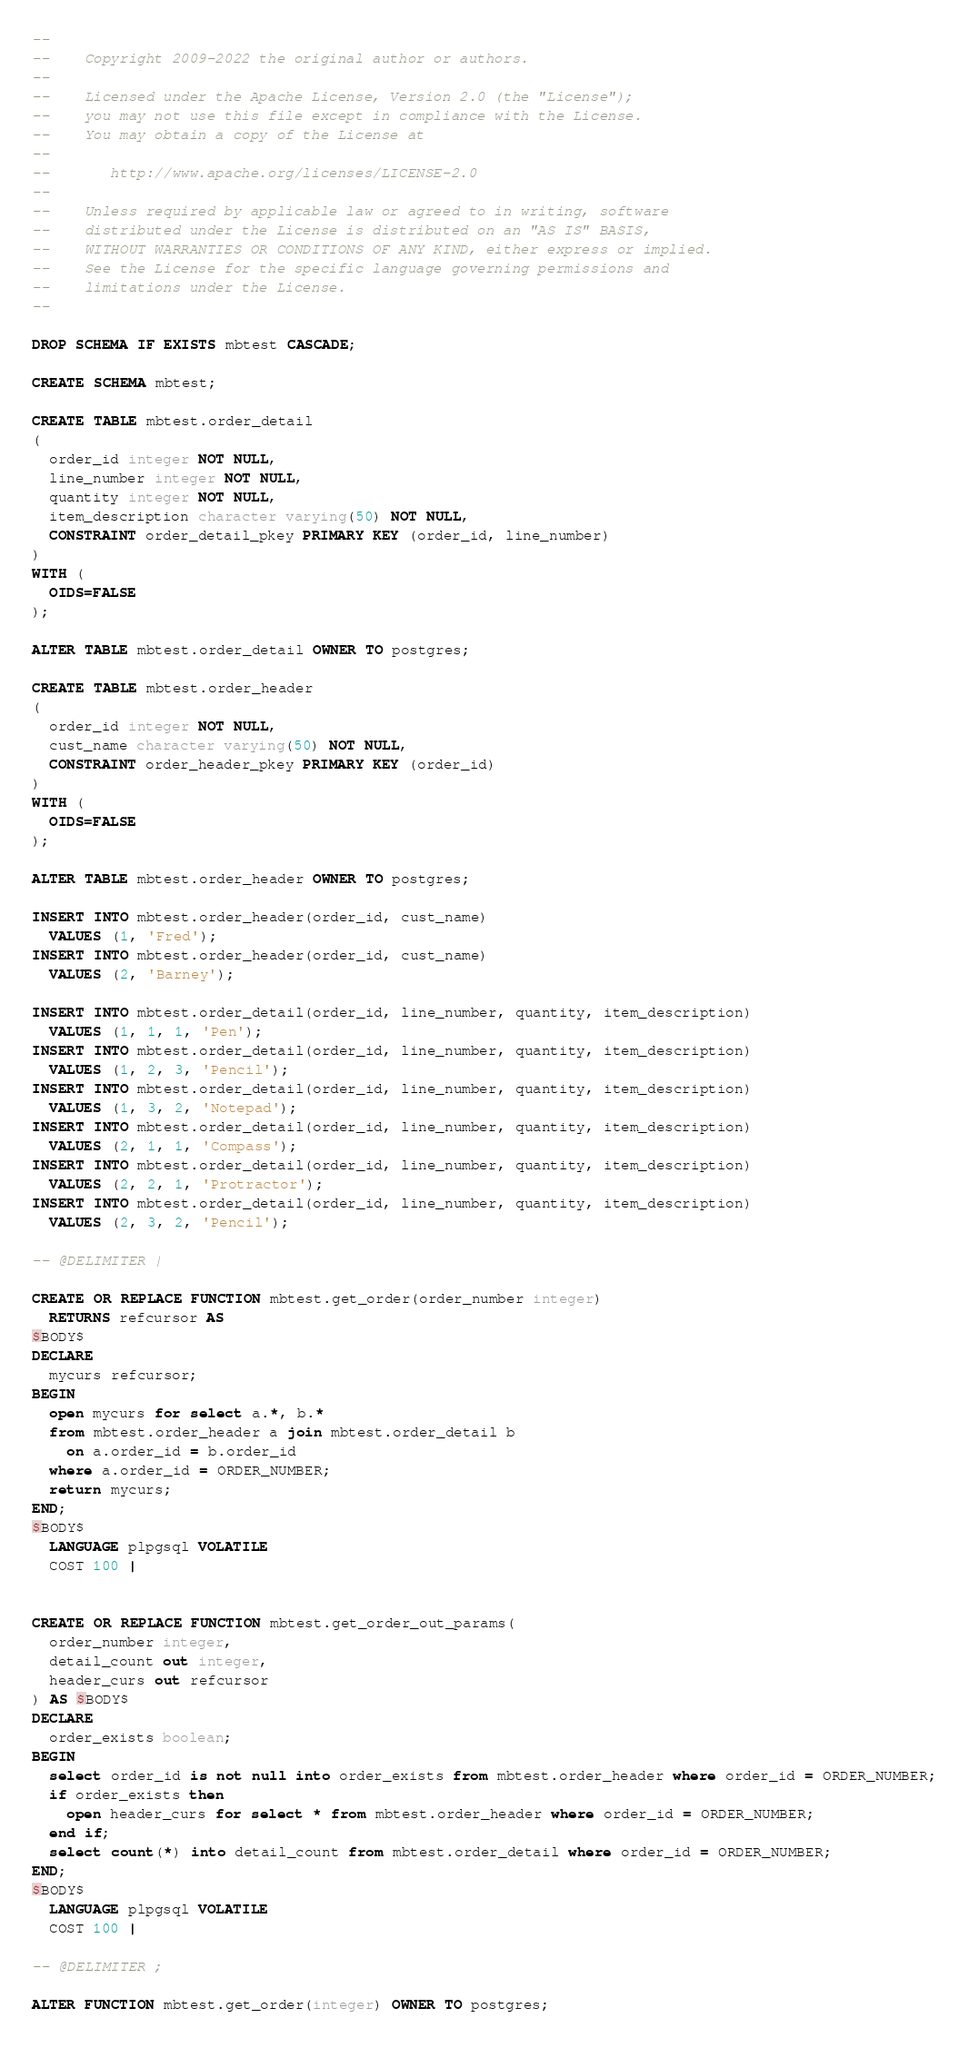Convert code to text. <code><loc_0><loc_0><loc_500><loc_500><_SQL_>--
--    Copyright 2009-2022 the original author or authors.
--
--    Licensed under the Apache License, Version 2.0 (the "License");
--    you may not use this file except in compliance with the License.
--    You may obtain a copy of the License at
--
--       http://www.apache.org/licenses/LICENSE-2.0
--
--    Unless required by applicable law or agreed to in writing, software
--    distributed under the License is distributed on an "AS IS" BASIS,
--    WITHOUT WARRANTIES OR CONDITIONS OF ANY KIND, either express or implied.
--    See the License for the specific language governing permissions and
--    limitations under the License.
--

DROP SCHEMA IF EXISTS mbtest CASCADE;

CREATE SCHEMA mbtest;

CREATE TABLE mbtest.order_detail
(
  order_id integer NOT NULL,
  line_number integer NOT NULL,
  quantity integer NOT NULL,
  item_description character varying(50) NOT NULL,
  CONSTRAINT order_detail_pkey PRIMARY KEY (order_id, line_number)
)
WITH (
  OIDS=FALSE
);

ALTER TABLE mbtest.order_detail OWNER TO postgres;

CREATE TABLE mbtest.order_header
(
  order_id integer NOT NULL,
  cust_name character varying(50) NOT NULL,
  CONSTRAINT order_header_pkey PRIMARY KEY (order_id)
)
WITH (
  OIDS=FALSE
);

ALTER TABLE mbtest.order_header OWNER TO postgres;

INSERT INTO mbtest.order_header(order_id, cust_name)
  VALUES (1, 'Fred');
INSERT INTO mbtest.order_header(order_id, cust_name)
  VALUES (2, 'Barney');

INSERT INTO mbtest.order_detail(order_id, line_number, quantity, item_description)
  VALUES (1, 1, 1, 'Pen');
INSERT INTO mbtest.order_detail(order_id, line_number, quantity, item_description)
  VALUES (1, 2, 3, 'Pencil');
INSERT INTO mbtest.order_detail(order_id, line_number, quantity, item_description)
  VALUES (1, 3, 2, 'Notepad');
INSERT INTO mbtest.order_detail(order_id, line_number, quantity, item_description)
  VALUES (2, 1, 1, 'Compass');
INSERT INTO mbtest.order_detail(order_id, line_number, quantity, item_description)
  VALUES (2, 2, 1, 'Protractor');
INSERT INTO mbtest.order_detail(order_id, line_number, quantity, item_description)
  VALUES (2, 3, 2, 'Pencil');

-- @DELIMITER |

CREATE OR REPLACE FUNCTION mbtest.get_order(order_number integer)
  RETURNS refcursor AS
$BODY$
DECLARE
  mycurs refcursor;
BEGIN
  open mycurs for select a.*, b.*
  from mbtest.order_header a join mbtest.order_detail b
    on a.order_id = b.order_id
  where a.order_id = ORDER_NUMBER;
  return mycurs;
END;
$BODY$
  LANGUAGE plpgsql VOLATILE
  COST 100 |


CREATE OR REPLACE FUNCTION mbtest.get_order_out_params(
  order_number integer,
  detail_count out integer,
  header_curs out refcursor
) AS $BODY$
DECLARE
  order_exists boolean;
BEGIN
  select order_id is not null into order_exists from mbtest.order_header where order_id = ORDER_NUMBER;
  if order_exists then
    open header_curs for select * from mbtest.order_header where order_id = ORDER_NUMBER;
  end if;
  select count(*) into detail_count from mbtest.order_detail where order_id = ORDER_NUMBER;
END;
$BODY$
  LANGUAGE plpgsql VOLATILE
  COST 100 |

-- @DELIMITER ;

ALTER FUNCTION mbtest.get_order(integer) OWNER TO postgres;
</code> 